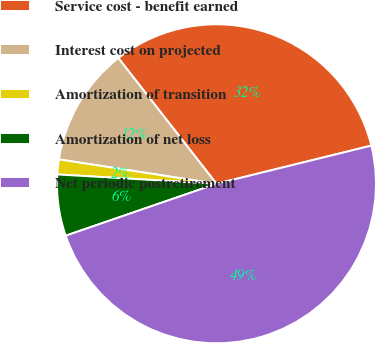Convert chart to OTSL. <chart><loc_0><loc_0><loc_500><loc_500><pie_chart><fcel>Service cost - benefit earned<fcel>Interest cost on projected<fcel>Amortization of transition<fcel>Amortization of net loss<fcel>Net periodic postretirement<nl><fcel>31.7%<fcel>12.01%<fcel>1.51%<fcel>6.21%<fcel>48.57%<nl></chart> 